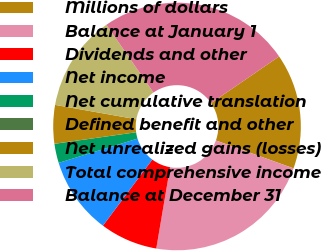Convert chart to OTSL. <chart><loc_0><loc_0><loc_500><loc_500><pie_chart><fcel>Millions of dollars<fcel>Balance at January 1<fcel>Dividends and other<fcel>Net income<fcel>Net cumulative translation<fcel>Defined benefit and other<fcel>Net unrealized gains (losses)<fcel>Total comprehensive income<fcel>Balance at December 31<nl><fcel>15.06%<fcel>22.19%<fcel>7.53%<fcel>10.04%<fcel>2.51%<fcel>0.01%<fcel>5.02%<fcel>12.55%<fcel>25.09%<nl></chart> 